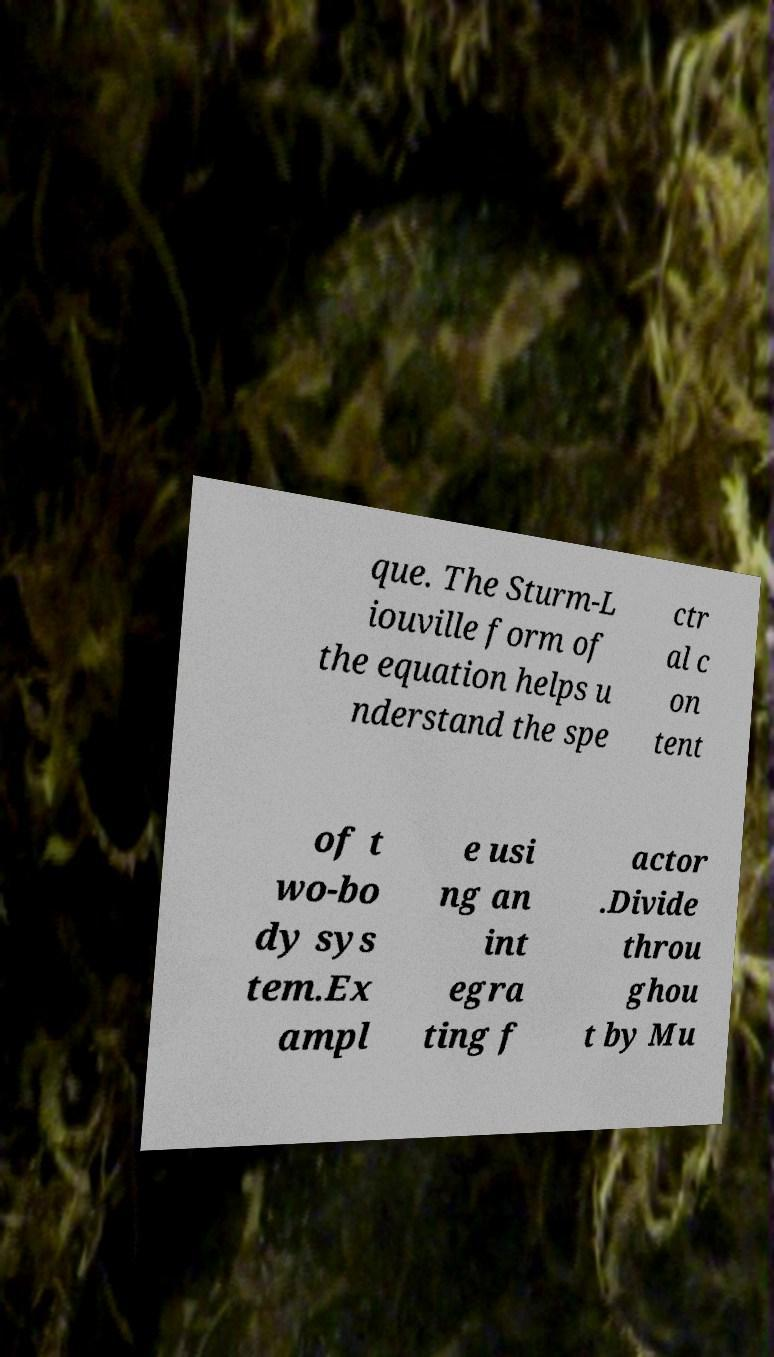Can you read and provide the text displayed in the image?This photo seems to have some interesting text. Can you extract and type it out for me? que. The Sturm-L iouville form of the equation helps u nderstand the spe ctr al c on tent of t wo-bo dy sys tem.Ex ampl e usi ng an int egra ting f actor .Divide throu ghou t by Mu 